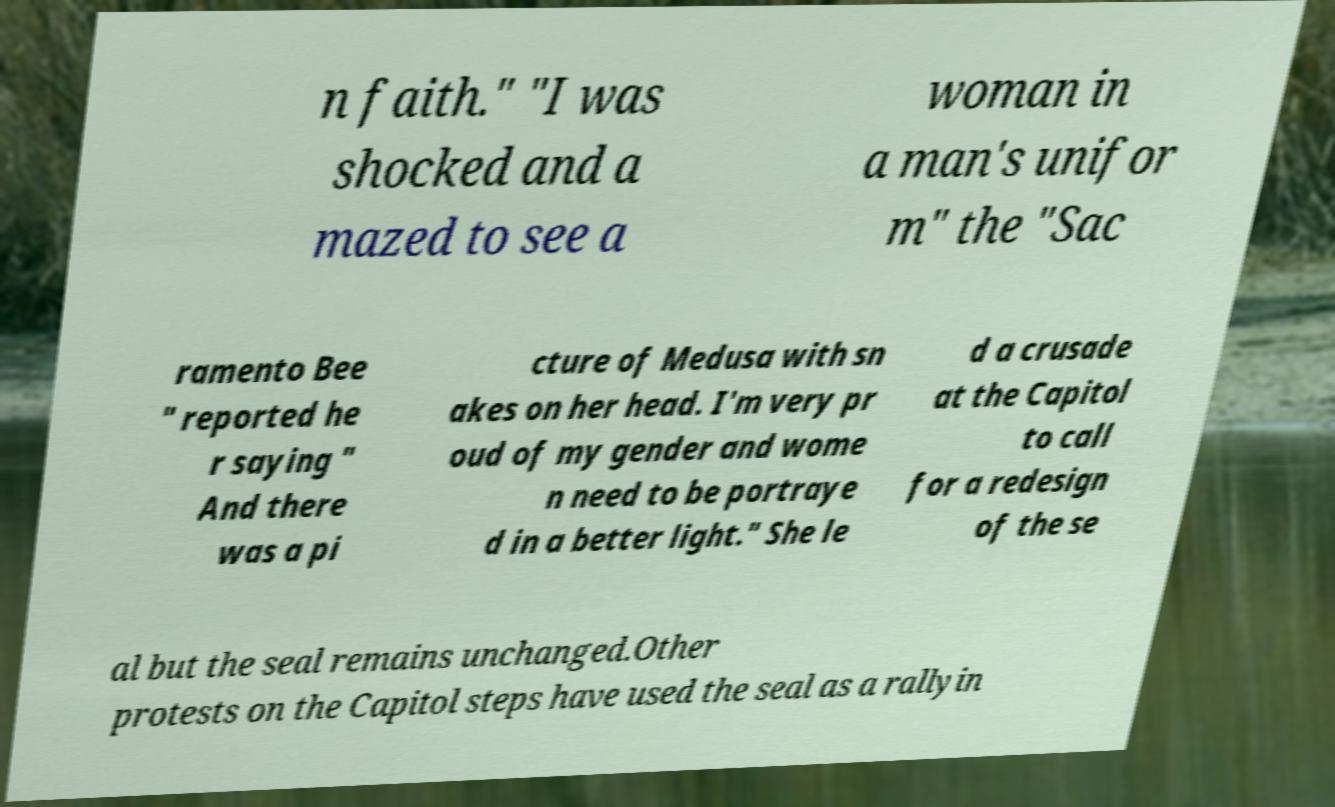Could you extract and type out the text from this image? n faith." "I was shocked and a mazed to see a woman in a man's unifor m" the "Sac ramento Bee " reported he r saying " And there was a pi cture of Medusa with sn akes on her head. I'm very pr oud of my gender and wome n need to be portraye d in a better light." She le d a crusade at the Capitol to call for a redesign of the se al but the seal remains unchanged.Other protests on the Capitol steps have used the seal as a rallyin 